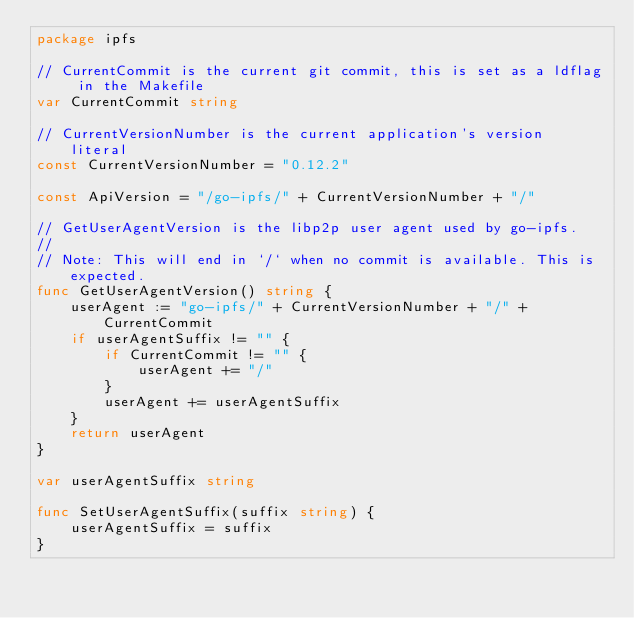<code> <loc_0><loc_0><loc_500><loc_500><_Go_>package ipfs

// CurrentCommit is the current git commit, this is set as a ldflag in the Makefile
var CurrentCommit string

// CurrentVersionNumber is the current application's version literal
const CurrentVersionNumber = "0.12.2"

const ApiVersion = "/go-ipfs/" + CurrentVersionNumber + "/"

// GetUserAgentVersion is the libp2p user agent used by go-ipfs.
//
// Note: This will end in `/` when no commit is available. This is expected.
func GetUserAgentVersion() string {
	userAgent := "go-ipfs/" + CurrentVersionNumber + "/" + CurrentCommit
	if userAgentSuffix != "" {
		if CurrentCommit != "" {
			userAgent += "/"
		}
		userAgent += userAgentSuffix
	}
	return userAgent
}

var userAgentSuffix string

func SetUserAgentSuffix(suffix string) {
	userAgentSuffix = suffix
}
</code> 